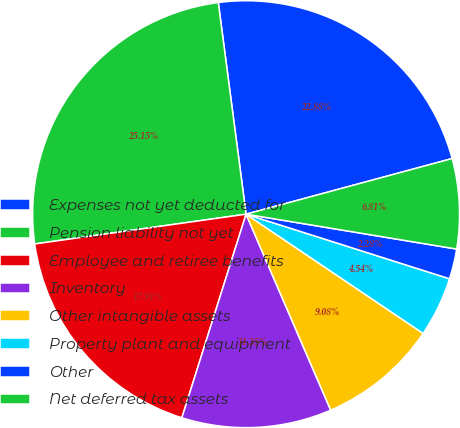Convert chart to OTSL. <chart><loc_0><loc_0><loc_500><loc_500><pie_chart><fcel>Expenses not yet deducted for<fcel>Pension liability not yet<fcel>Employee and retiree benefits<fcel>Inventory<fcel>Other intangible assets<fcel>Property plant and equipment<fcel>Other<fcel>Net deferred tax assets<nl><fcel>22.88%<fcel>25.15%<fcel>17.91%<fcel>11.35%<fcel>9.08%<fcel>4.54%<fcel>2.28%<fcel>6.81%<nl></chart> 